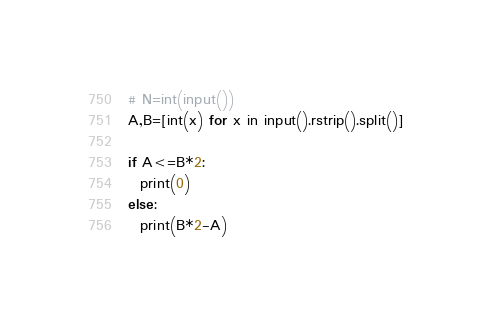Convert code to text. <code><loc_0><loc_0><loc_500><loc_500><_Python_># N=int(input())
A,B=[int(x) for x in input().rstrip().split()]

if A<=B*2:
  print(0)
else:
  print(B*2-A)</code> 